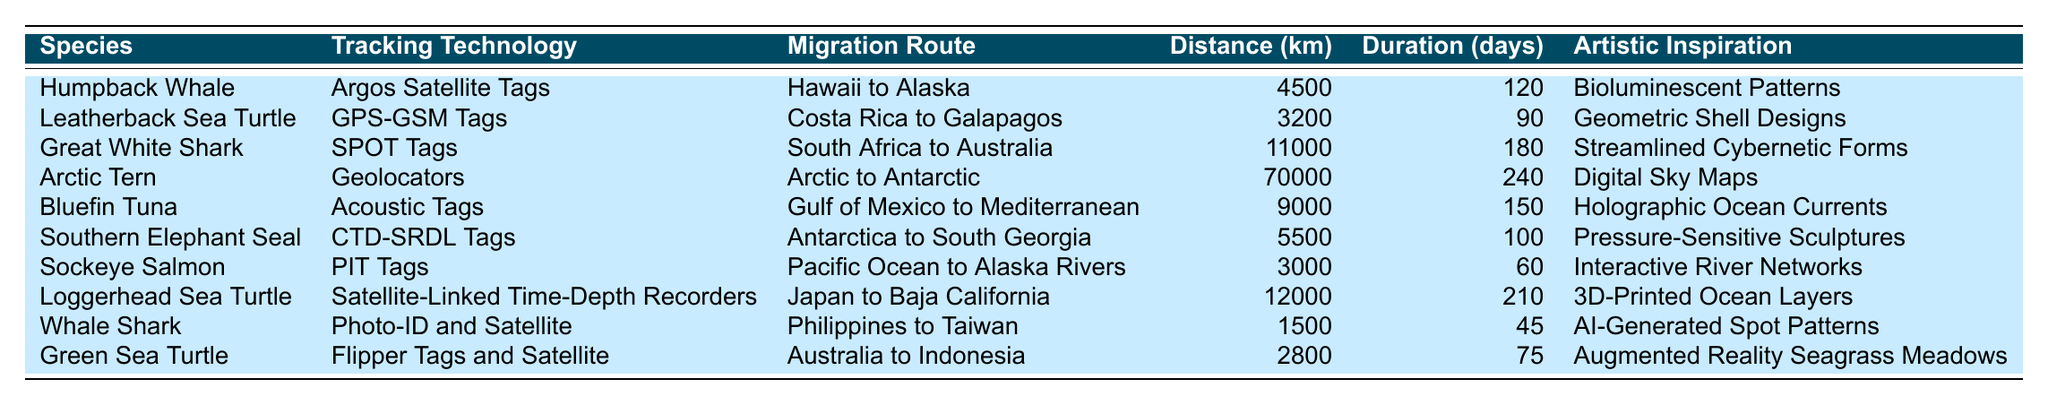What species travels the longest distance? By examining the "Distance Traveled (km)" column, the Arctic Tern is listed with a migration distance of 70,000 km, which is the highest among all the species.
Answer: Arctic Tern Which species has the shortest migration duration? The "Duration (days)" column shows that the Whale Shark has the shortest migration duration of 45 days, which is less than any other species presented in the table.
Answer: Whale Shark How many kilometers does the Great White Shark migrate? The table indicates that the Great White Shark migrates a total of 11,000 km as listed in the "Distance Traveled (km)" column.
Answer: 11000 km What is the average duration of migration for the Loggerhead Sea Turtle and the Bluefin Tuna? We sum the durations: Loggerhead Sea Turtle = 210 days, Bluefin Tuna = 150 days. The total is 210 + 150 = 360 days. There are 2 species, so the average is 360 / 2 = 180 days.
Answer: 180 days Is the Leatherback Sea Turtle's migration distance greater than the Southern Elephant Seal's? The Leatherback Sea Turtle migrates 3,200 km, while the Southern Elephant Seal travels 5,500 km. Since 3,200 km is less than 5,500 km, the answer is no.
Answer: No What is the total distance traveled by the Humpback Whale and the Sockeye Salmon combined? Adding their distances: Humpback Whale = 4,500 km and Sockeye Salmon = 3,000 km. The total distance is 4,500 + 3,000 = 7,500 km.
Answer: 7500 km Which tracking technology is used for the Loggerhead Sea Turtle? According to the table, the Loggerhead Sea Turtle uses "Satellite-Linked Time-Depth Recorders" as its tracking technology.
Answer: Satellite-Linked Time-Depth Recorders Are any species listed using GPS technology? The Leatherback Sea Turtle is the only species listed in the table that uses GPS technology, specifically "GPS-GSM Tags."
Answer: Yes What is the difference in migration distance between the Southern Elephant Seal and the Green Sea Turtle? The Southern Elephant Seal migrates 5,500 km and the Green Sea Turtle migrates 2,800 km. The difference is 5,500 - 2,800 = 2,700 km.
Answer: 2700 km List the artistic inspirations associated with the Great White Shark and the Arctic Tern. The Great White Shark's artistic inspiration is "Streamlined Cybernetic Forms," while the Arctic Tern's inspiration is "Digital Sky Maps."
Answer: Streamlined Cybernetic Forms, Digital Sky Maps 